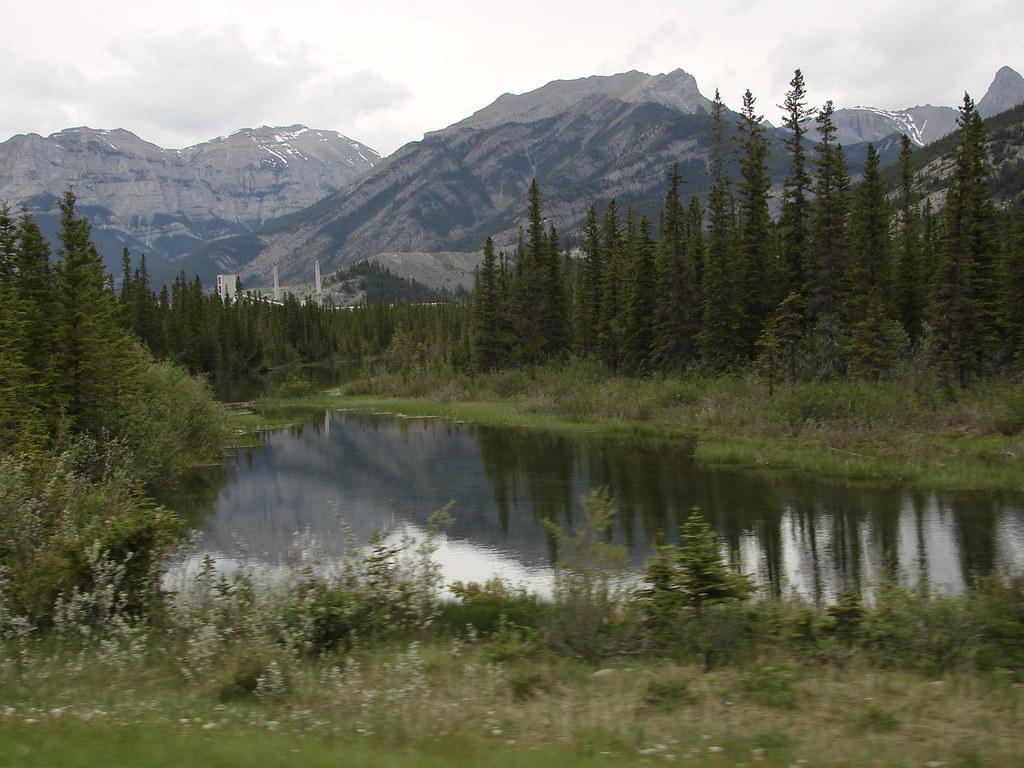In one or two sentences, can you explain what this image depicts? In this picture I can observe a small pond. There are some plants and trees in the middle of the picture. In the background there are mountains and clouds in the sky. 